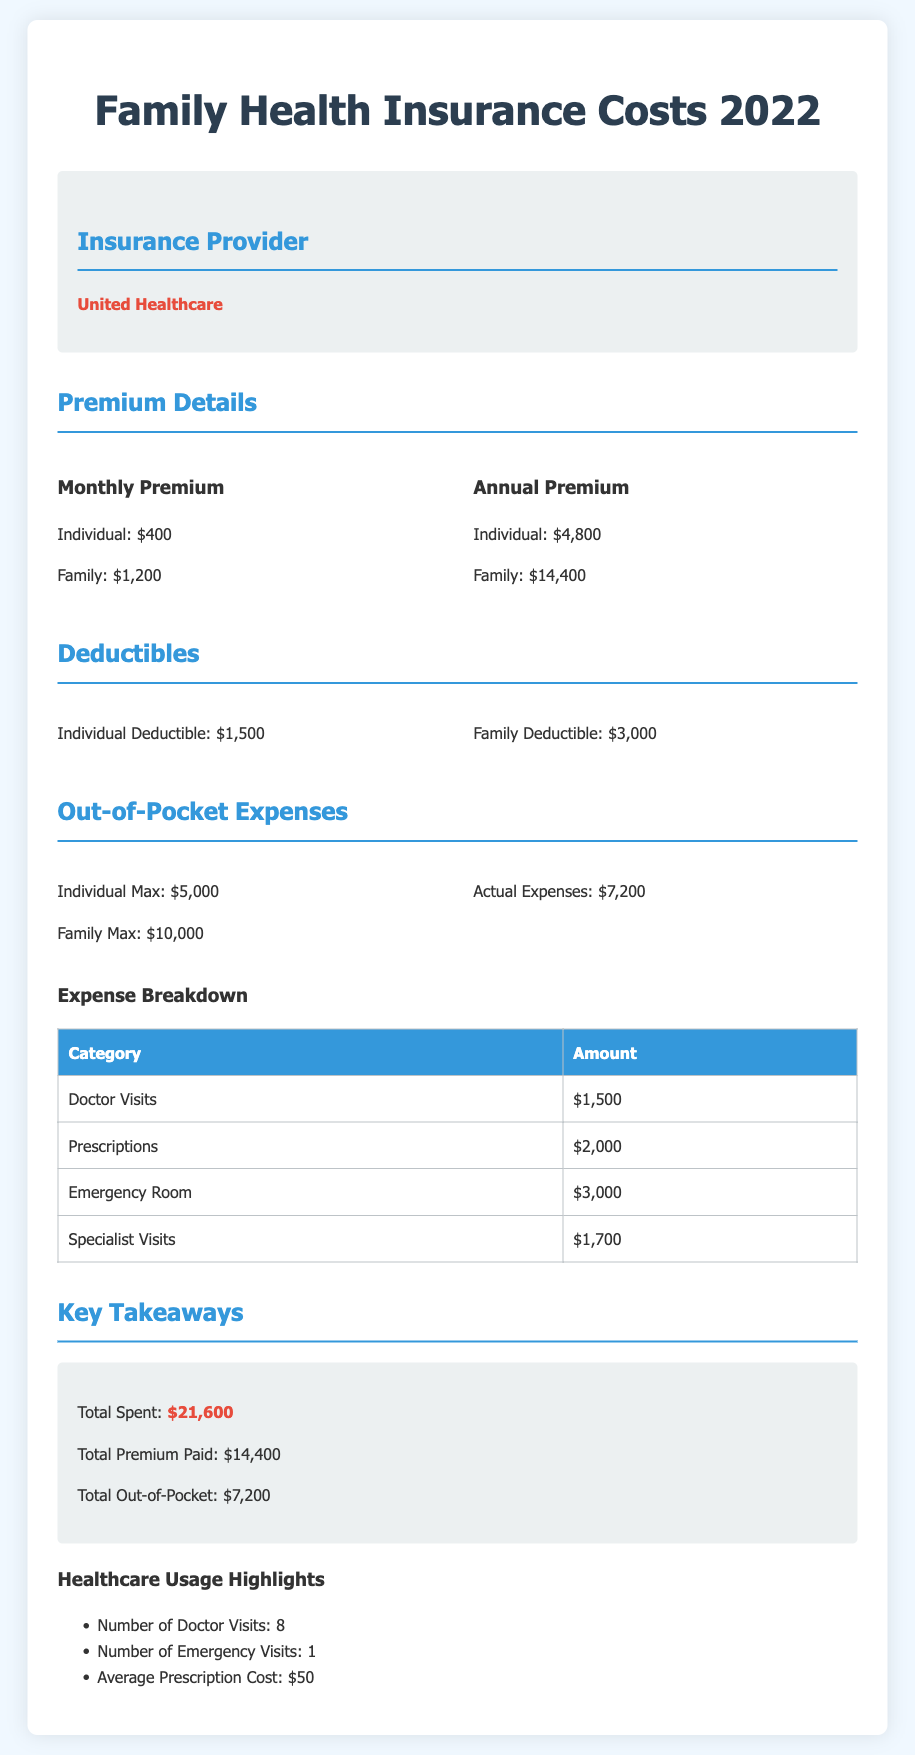What was the insurance provider? The document states that the insurance provider is highlighted for clarity.
Answer: United Healthcare What is the annual premium for a family? The annual premium for a family is listed in the premium details section.
Answer: $14,400 What is the individual deductible amount? The individual deductible is specified in the deductible section of the document.
Answer: $1,500 What were the actual out-of-pocket expenses incurred? The actual expenses are provided under the out-of-pocket expenses section.
Answer: $7,200 What was the total amount spent on healthcare? The total spent is presented in the key takeaways section of the report.
Answer: $21,600 How many doctor visits were recorded? The number of doctor visits is highlighted in the healthcare usage highlights section.
Answer: 8 What was the emergency room cost? The cost for the emergency room is included in the expense breakdown table.
Answer: $3,000 What is the family max out-of-pocket expense? The family max out-of-pocket is stated in the out-of-pocket expenses section.
Answer: $10,000 